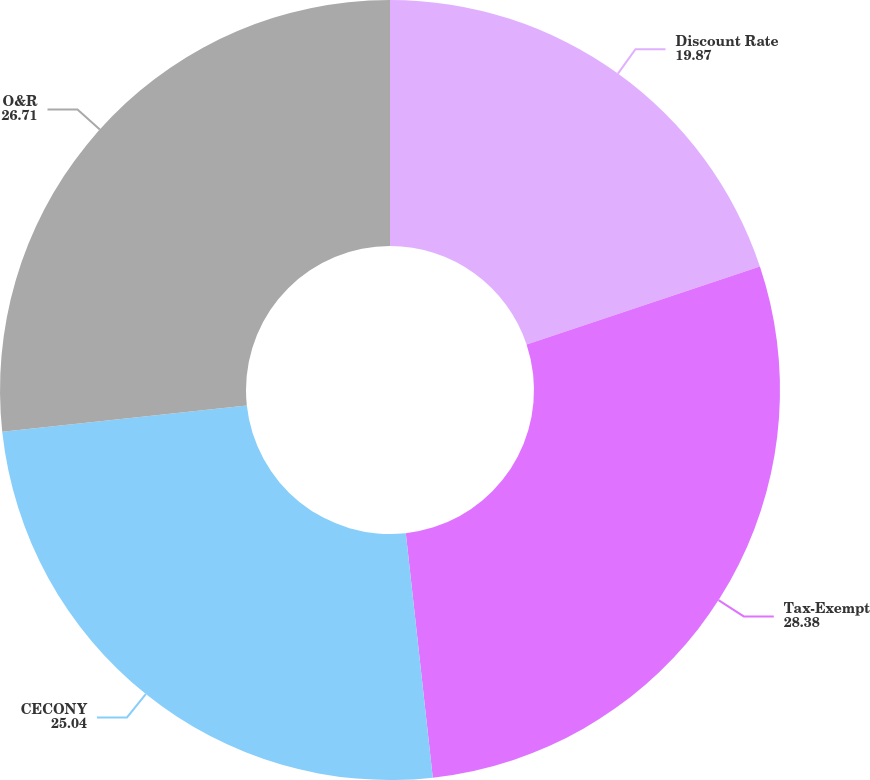Convert chart to OTSL. <chart><loc_0><loc_0><loc_500><loc_500><pie_chart><fcel>Discount Rate<fcel>Tax-Exempt<fcel>CECONY<fcel>O&R<nl><fcel>19.87%<fcel>28.38%<fcel>25.04%<fcel>26.71%<nl></chart> 